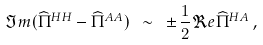Convert formula to latex. <formula><loc_0><loc_0><loc_500><loc_500>\Im m ( \widehat { \Pi } ^ { H H } - \widehat { \Pi } ^ { A A } ) \ \sim \ \pm \, \frac { 1 } { 2 } \Re e \widehat { \Pi } ^ { H A } \, ,</formula> 